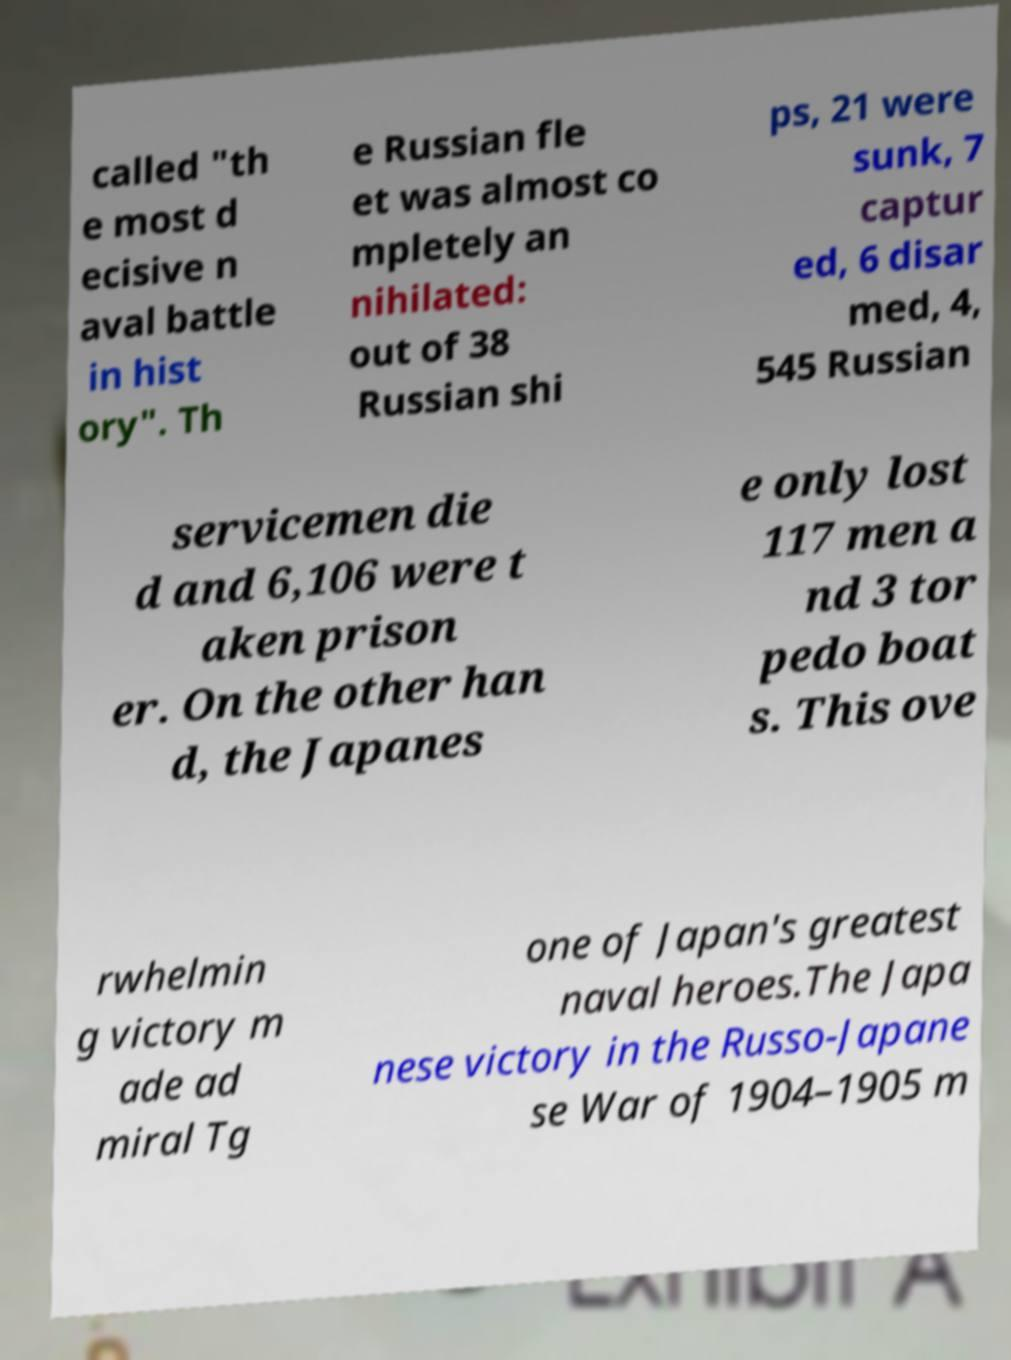Could you assist in decoding the text presented in this image and type it out clearly? called "th e most d ecisive n aval battle in hist ory". Th e Russian fle et was almost co mpletely an nihilated: out of 38 Russian shi ps, 21 were sunk, 7 captur ed, 6 disar med, 4, 545 Russian servicemen die d and 6,106 were t aken prison er. On the other han d, the Japanes e only lost 117 men a nd 3 tor pedo boat s. This ove rwhelmin g victory m ade ad miral Tg one of Japan's greatest naval heroes.The Japa nese victory in the Russo-Japane se War of 1904–1905 m 